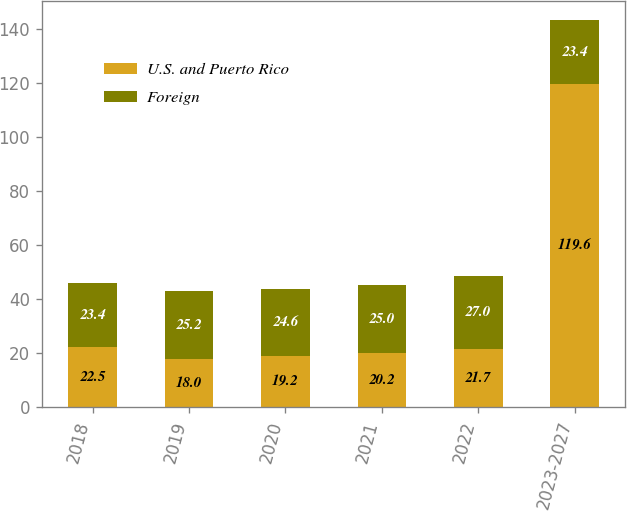Convert chart to OTSL. <chart><loc_0><loc_0><loc_500><loc_500><stacked_bar_chart><ecel><fcel>2018<fcel>2019<fcel>2020<fcel>2021<fcel>2022<fcel>2023-2027<nl><fcel>U.S. and Puerto Rico<fcel>22.5<fcel>18<fcel>19.2<fcel>20.2<fcel>21.7<fcel>119.6<nl><fcel>Foreign<fcel>23.4<fcel>25.2<fcel>24.6<fcel>25<fcel>27<fcel>23.4<nl></chart> 